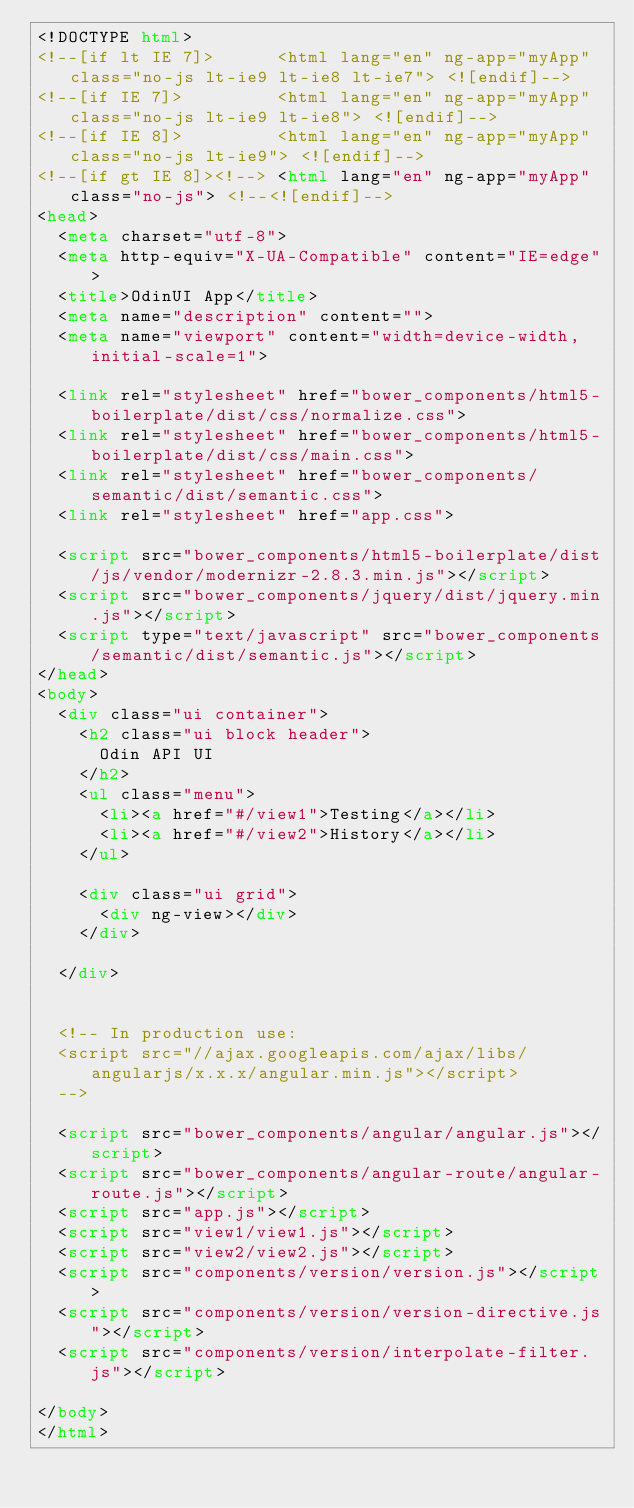Convert code to text. <code><loc_0><loc_0><loc_500><loc_500><_HTML_><!DOCTYPE html>
<!--[if lt IE 7]>      <html lang="en" ng-app="myApp" class="no-js lt-ie9 lt-ie8 lt-ie7"> <![endif]-->
<!--[if IE 7]>         <html lang="en" ng-app="myApp" class="no-js lt-ie9 lt-ie8"> <![endif]-->
<!--[if IE 8]>         <html lang="en" ng-app="myApp" class="no-js lt-ie9"> <![endif]-->
<!--[if gt IE 8]><!--> <html lang="en" ng-app="myApp" class="no-js"> <!--<![endif]-->
<head>
  <meta charset="utf-8">
  <meta http-equiv="X-UA-Compatible" content="IE=edge">
  <title>OdinUI App</title>
  <meta name="description" content="">
  <meta name="viewport" content="width=device-width, initial-scale=1">

  <link rel="stylesheet" href="bower_components/html5-boilerplate/dist/css/normalize.css">
  <link rel="stylesheet" href="bower_components/html5-boilerplate/dist/css/main.css">
  <link rel="stylesheet" href="bower_components/semantic/dist/semantic.css">
  <link rel="stylesheet" href="app.css">

  <script src="bower_components/html5-boilerplate/dist/js/vendor/modernizr-2.8.3.min.js"></script>
  <script src="bower_components/jquery/dist/jquery.min.js"></script>
  <script type="text/javascript" src="bower_components/semantic/dist/semantic.js"></script>
</head>
<body>
  <div class="ui container">
    <h2 class="ui block header">
      Odin API UI 
    </h2>
    <ul class="menu">
      <li><a href="#/view1">Testing</a></li>
      <li><a href="#/view2">History</a></li>
    </ul>

    <div class="ui grid">
      <div ng-view></div> 
    </div>
  
  </div>
  

  <!-- In production use:
  <script src="//ajax.googleapis.com/ajax/libs/angularjs/x.x.x/angular.min.js"></script>
  -->

  <script src="bower_components/angular/angular.js"></script>
  <script src="bower_components/angular-route/angular-route.js"></script>
  <script src="app.js"></script>
  <script src="view1/view1.js"></script>
  <script src="view2/view2.js"></script>
  <script src="components/version/version.js"></script>
  <script src="components/version/version-directive.js"></script>
  <script src="components/version/interpolate-filter.js"></script>
 
</body>
</html>
</code> 